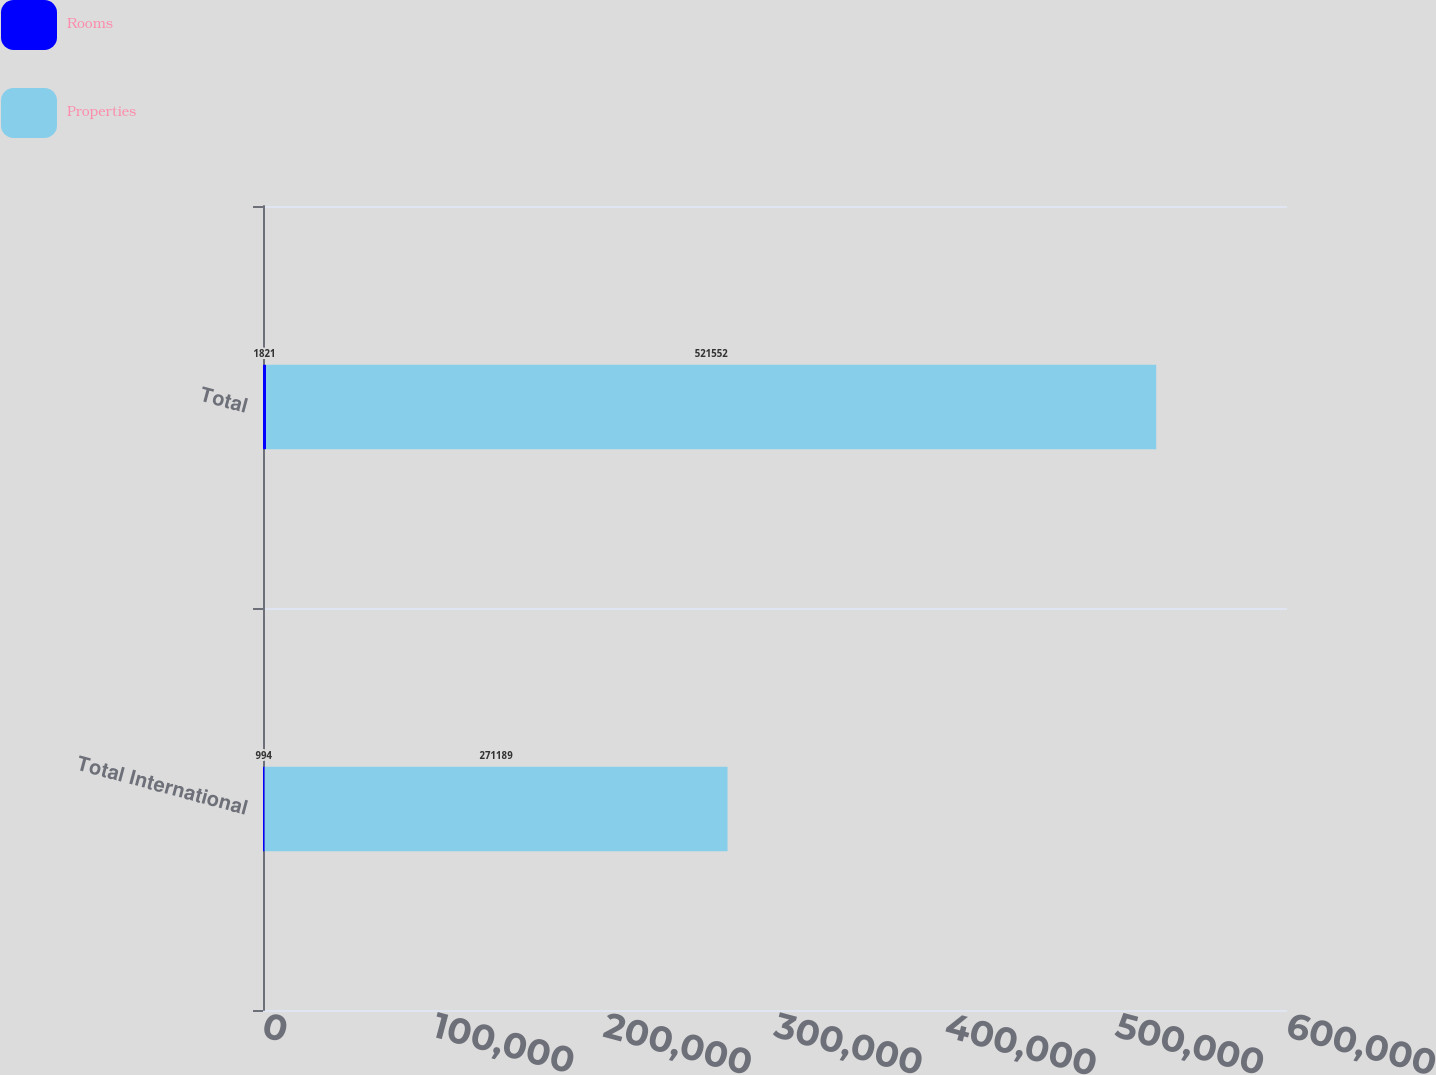Convert chart. <chart><loc_0><loc_0><loc_500><loc_500><stacked_bar_chart><ecel><fcel>Total International<fcel>Total<nl><fcel>Rooms<fcel>994<fcel>1821<nl><fcel>Properties<fcel>271189<fcel>521552<nl></chart> 